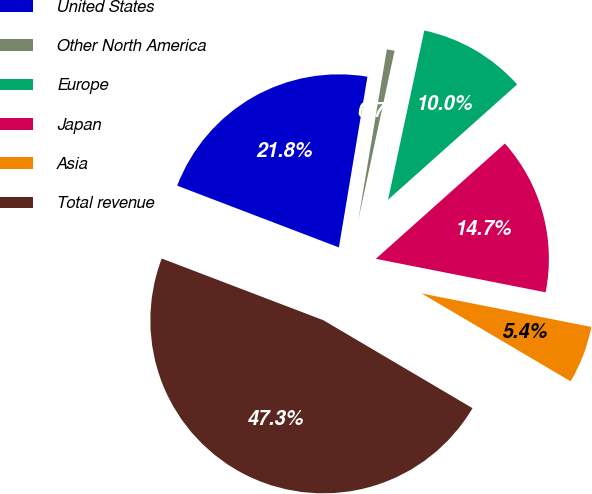Convert chart to OTSL. <chart><loc_0><loc_0><loc_500><loc_500><pie_chart><fcel>United States<fcel>Other North America<fcel>Europe<fcel>Japan<fcel>Asia<fcel>Total revenue<nl><fcel>21.83%<fcel>0.72%<fcel>10.04%<fcel>14.7%<fcel>5.38%<fcel>47.32%<nl></chart> 